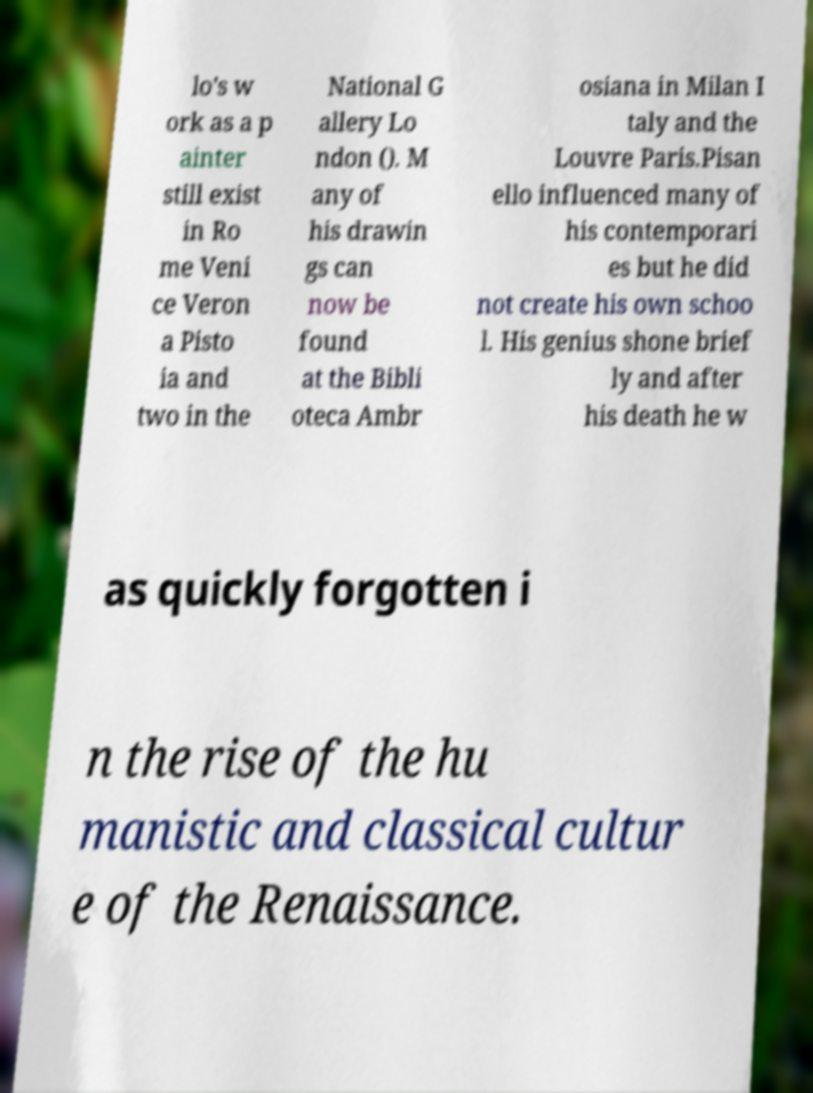Please read and relay the text visible in this image. What does it say? lo's w ork as a p ainter still exist in Ro me Veni ce Veron a Pisto ia and two in the National G allery Lo ndon (). M any of his drawin gs can now be found at the Bibli oteca Ambr osiana in Milan I taly and the Louvre Paris.Pisan ello influenced many of his contemporari es but he did not create his own schoo l. His genius shone brief ly and after his death he w as quickly forgotten i n the rise of the hu manistic and classical cultur e of the Renaissance. 